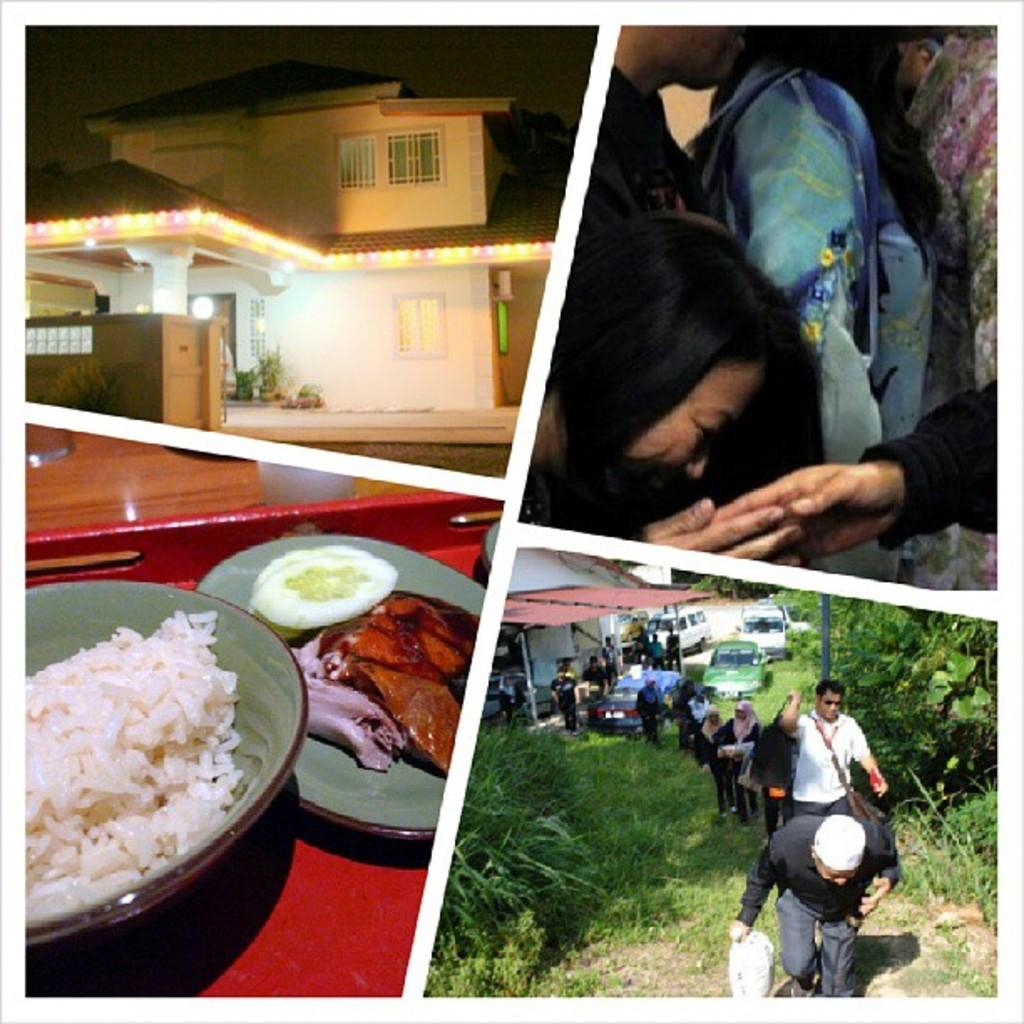What type of artwork is the image? The image is a collage. What structures can be seen in the collage? There are buildings in the image. What architectural features are visible in the buildings? There are windows in the image. What lighting elements are present in the collage? There are lights in the image. What mode of transportation is depicted in the image? There are vehicles in the image. What type of natural environment is featured in the collage? There is grass in the image. What type of vegetation is present in the collage? There are plants in the image. What type of food items can be seen in the image? There are food items in the image. What type of dishware is present in the image? There is a bowl and a plate in the image. How many people are present in the image? There is a group of people in the image. What other objects can be seen in the collage? There are various objects in the image. What is the tendency of the cakes to move around in the image? There are no cakes present in the image, so it is not possible to determine their tendency to move around. 